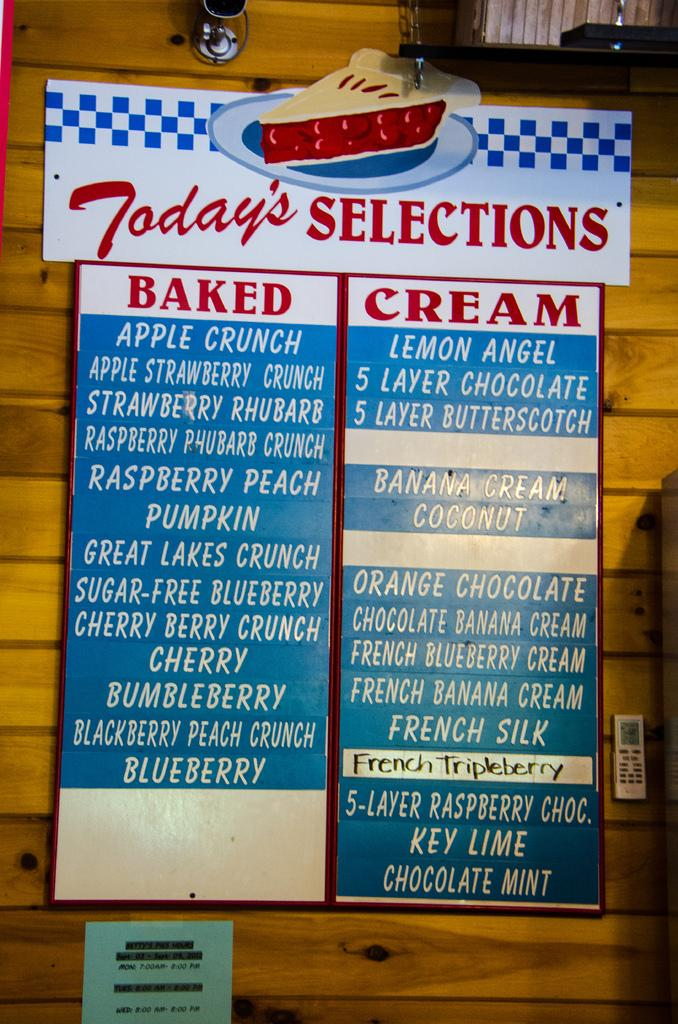<image>
Render a clear and concise summary of the photo. A long list of pies is under a sign that says "Today's Selections." 